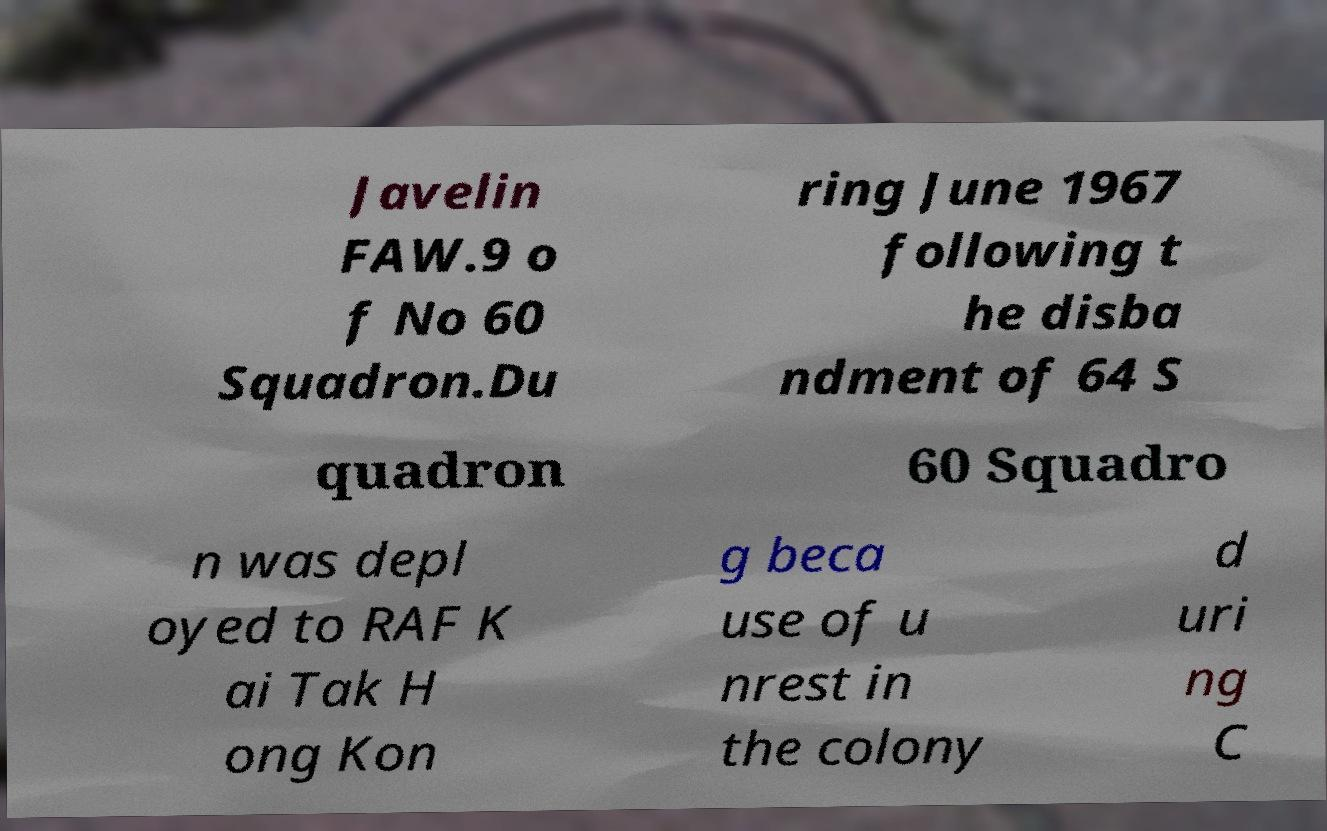Can you accurately transcribe the text from the provided image for me? Javelin FAW.9 o f No 60 Squadron.Du ring June 1967 following t he disba ndment of 64 S quadron 60 Squadro n was depl oyed to RAF K ai Tak H ong Kon g beca use of u nrest in the colony d uri ng C 